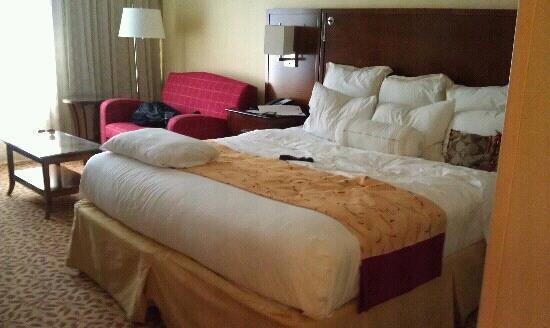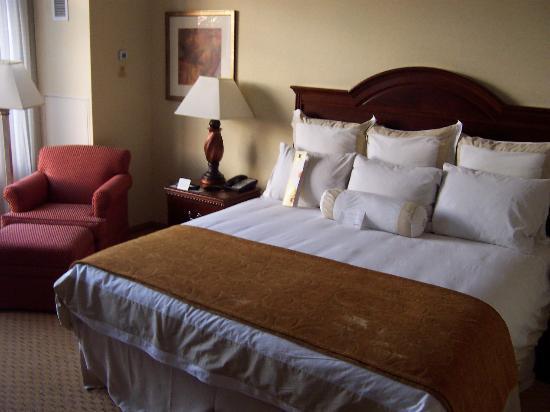The first image is the image on the left, the second image is the image on the right. Examine the images to the left and right. Is the description "both bedframes are brown" accurate? Answer yes or no. Yes. 